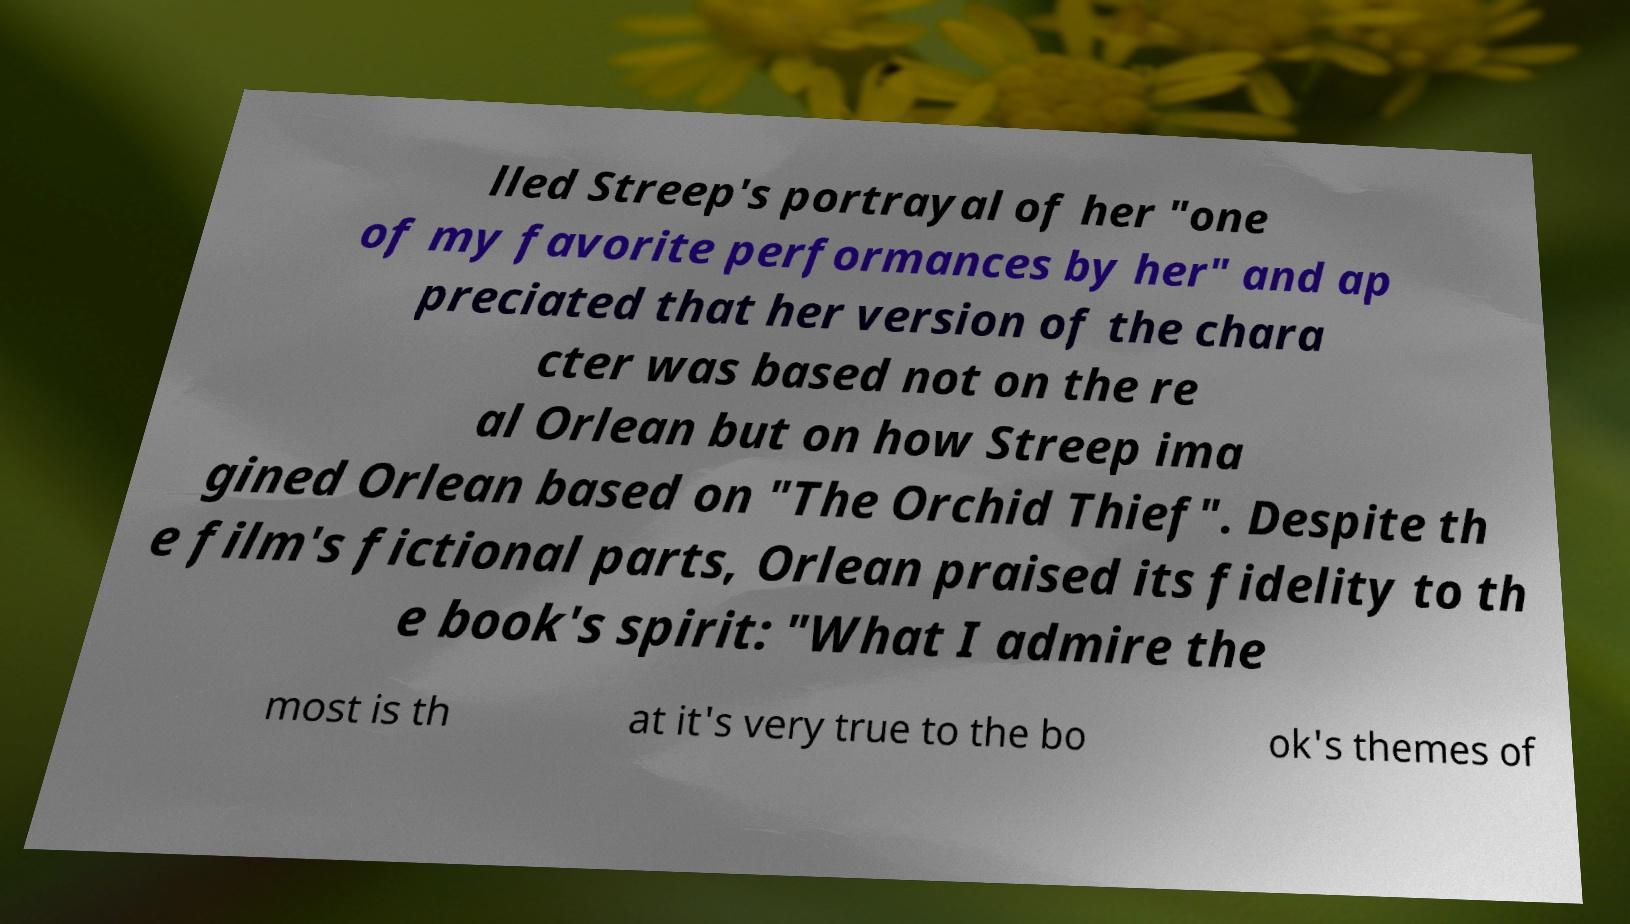Can you read and provide the text displayed in the image?This photo seems to have some interesting text. Can you extract and type it out for me? lled Streep's portrayal of her "one of my favorite performances by her" and ap preciated that her version of the chara cter was based not on the re al Orlean but on how Streep ima gined Orlean based on "The Orchid Thief". Despite th e film's fictional parts, Orlean praised its fidelity to th e book's spirit: "What I admire the most is th at it's very true to the bo ok's themes of 